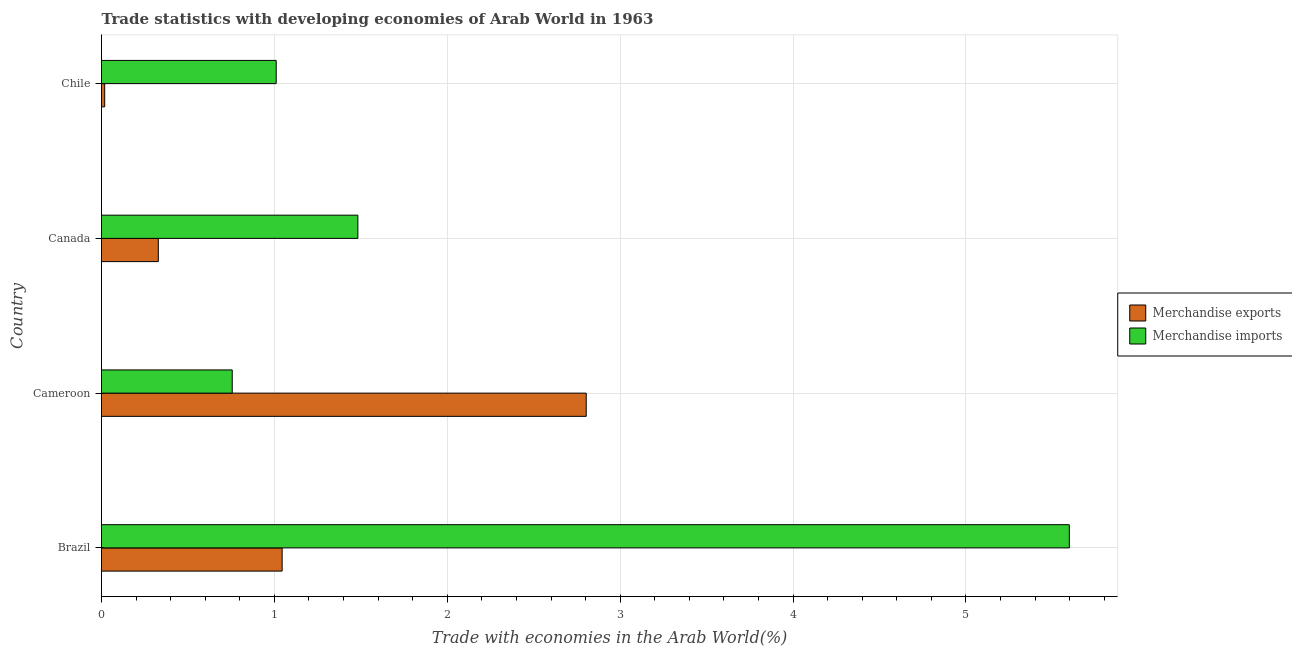How many different coloured bars are there?
Your answer should be compact. 2. How many bars are there on the 1st tick from the top?
Your response must be concise. 2. What is the label of the 2nd group of bars from the top?
Offer a very short reply. Canada. In how many cases, is the number of bars for a given country not equal to the number of legend labels?
Offer a very short reply. 0. What is the merchandise imports in Chile?
Your answer should be compact. 1.01. Across all countries, what is the maximum merchandise imports?
Offer a terse response. 5.6. Across all countries, what is the minimum merchandise imports?
Ensure brevity in your answer.  0.76. In which country was the merchandise imports maximum?
Your answer should be very brief. Brazil. In which country was the merchandise imports minimum?
Your answer should be very brief. Cameroon. What is the total merchandise imports in the graph?
Offer a terse response. 8.85. What is the difference between the merchandise exports in Canada and that in Chile?
Ensure brevity in your answer.  0.31. What is the difference between the merchandise exports in Brazil and the merchandise imports in Chile?
Your answer should be very brief. 0.03. What is the average merchandise exports per country?
Keep it short and to the point. 1.05. What is the difference between the merchandise exports and merchandise imports in Cameroon?
Offer a very short reply. 2.05. In how many countries, is the merchandise exports greater than 2.4 %?
Provide a short and direct response. 1. What is the ratio of the merchandise exports in Canada to that in Chile?
Your response must be concise. 17.8. Is the merchandise exports in Canada less than that in Chile?
Offer a terse response. No. Is the difference between the merchandise imports in Cameroon and Canada greater than the difference between the merchandise exports in Cameroon and Canada?
Make the answer very short. No. What is the difference between the highest and the second highest merchandise exports?
Provide a succinct answer. 1.76. What is the difference between the highest and the lowest merchandise exports?
Keep it short and to the point. 2.79. In how many countries, is the merchandise imports greater than the average merchandise imports taken over all countries?
Make the answer very short. 1. Is the sum of the merchandise imports in Cameroon and Canada greater than the maximum merchandise exports across all countries?
Your answer should be compact. No. What does the 1st bar from the bottom in Chile represents?
Give a very brief answer. Merchandise exports. Are all the bars in the graph horizontal?
Your answer should be compact. Yes. How many countries are there in the graph?
Ensure brevity in your answer.  4. What is the difference between two consecutive major ticks on the X-axis?
Your answer should be very brief. 1. What is the title of the graph?
Offer a terse response. Trade statistics with developing economies of Arab World in 1963. Does "Highest 20% of population" appear as one of the legend labels in the graph?
Your response must be concise. No. What is the label or title of the X-axis?
Your answer should be compact. Trade with economies in the Arab World(%). What is the label or title of the Y-axis?
Give a very brief answer. Country. What is the Trade with economies in the Arab World(%) in Merchandise exports in Brazil?
Ensure brevity in your answer.  1.04. What is the Trade with economies in the Arab World(%) in Merchandise imports in Brazil?
Provide a short and direct response. 5.6. What is the Trade with economies in the Arab World(%) in Merchandise exports in Cameroon?
Offer a very short reply. 2.8. What is the Trade with economies in the Arab World(%) in Merchandise imports in Cameroon?
Offer a very short reply. 0.76. What is the Trade with economies in the Arab World(%) of Merchandise exports in Canada?
Ensure brevity in your answer.  0.33. What is the Trade with economies in the Arab World(%) in Merchandise imports in Canada?
Your answer should be compact. 1.48. What is the Trade with economies in the Arab World(%) of Merchandise exports in Chile?
Offer a terse response. 0.02. What is the Trade with economies in the Arab World(%) in Merchandise imports in Chile?
Keep it short and to the point. 1.01. Across all countries, what is the maximum Trade with economies in the Arab World(%) in Merchandise exports?
Provide a short and direct response. 2.8. Across all countries, what is the maximum Trade with economies in the Arab World(%) of Merchandise imports?
Offer a very short reply. 5.6. Across all countries, what is the minimum Trade with economies in the Arab World(%) in Merchandise exports?
Your answer should be compact. 0.02. Across all countries, what is the minimum Trade with economies in the Arab World(%) of Merchandise imports?
Give a very brief answer. 0.76. What is the total Trade with economies in the Arab World(%) of Merchandise exports in the graph?
Provide a short and direct response. 4.2. What is the total Trade with economies in the Arab World(%) of Merchandise imports in the graph?
Your answer should be very brief. 8.85. What is the difference between the Trade with economies in the Arab World(%) in Merchandise exports in Brazil and that in Cameroon?
Offer a terse response. -1.76. What is the difference between the Trade with economies in the Arab World(%) in Merchandise imports in Brazil and that in Cameroon?
Give a very brief answer. 4.84. What is the difference between the Trade with economies in the Arab World(%) of Merchandise exports in Brazil and that in Canada?
Provide a short and direct response. 0.72. What is the difference between the Trade with economies in the Arab World(%) of Merchandise imports in Brazil and that in Canada?
Make the answer very short. 4.12. What is the difference between the Trade with economies in the Arab World(%) of Merchandise exports in Brazil and that in Chile?
Your answer should be very brief. 1.03. What is the difference between the Trade with economies in the Arab World(%) of Merchandise imports in Brazil and that in Chile?
Ensure brevity in your answer.  4.59. What is the difference between the Trade with economies in the Arab World(%) in Merchandise exports in Cameroon and that in Canada?
Your answer should be compact. 2.48. What is the difference between the Trade with economies in the Arab World(%) of Merchandise imports in Cameroon and that in Canada?
Provide a short and direct response. -0.73. What is the difference between the Trade with economies in the Arab World(%) of Merchandise exports in Cameroon and that in Chile?
Make the answer very short. 2.79. What is the difference between the Trade with economies in the Arab World(%) of Merchandise imports in Cameroon and that in Chile?
Your answer should be compact. -0.25. What is the difference between the Trade with economies in the Arab World(%) of Merchandise exports in Canada and that in Chile?
Offer a very short reply. 0.31. What is the difference between the Trade with economies in the Arab World(%) of Merchandise imports in Canada and that in Chile?
Offer a very short reply. 0.47. What is the difference between the Trade with economies in the Arab World(%) of Merchandise exports in Brazil and the Trade with economies in the Arab World(%) of Merchandise imports in Cameroon?
Provide a short and direct response. 0.29. What is the difference between the Trade with economies in the Arab World(%) in Merchandise exports in Brazil and the Trade with economies in the Arab World(%) in Merchandise imports in Canada?
Your response must be concise. -0.44. What is the difference between the Trade with economies in the Arab World(%) in Merchandise exports in Brazil and the Trade with economies in the Arab World(%) in Merchandise imports in Chile?
Make the answer very short. 0.03. What is the difference between the Trade with economies in the Arab World(%) in Merchandise exports in Cameroon and the Trade with economies in the Arab World(%) in Merchandise imports in Canada?
Give a very brief answer. 1.32. What is the difference between the Trade with economies in the Arab World(%) in Merchandise exports in Cameroon and the Trade with economies in the Arab World(%) in Merchandise imports in Chile?
Provide a succinct answer. 1.79. What is the difference between the Trade with economies in the Arab World(%) of Merchandise exports in Canada and the Trade with economies in the Arab World(%) of Merchandise imports in Chile?
Provide a short and direct response. -0.68. What is the average Trade with economies in the Arab World(%) in Merchandise exports per country?
Provide a succinct answer. 1.05. What is the average Trade with economies in the Arab World(%) of Merchandise imports per country?
Give a very brief answer. 2.21. What is the difference between the Trade with economies in the Arab World(%) in Merchandise exports and Trade with economies in the Arab World(%) in Merchandise imports in Brazil?
Offer a terse response. -4.55. What is the difference between the Trade with economies in the Arab World(%) of Merchandise exports and Trade with economies in the Arab World(%) of Merchandise imports in Cameroon?
Your answer should be very brief. 2.05. What is the difference between the Trade with economies in the Arab World(%) in Merchandise exports and Trade with economies in the Arab World(%) in Merchandise imports in Canada?
Your answer should be very brief. -1.15. What is the difference between the Trade with economies in the Arab World(%) of Merchandise exports and Trade with economies in the Arab World(%) of Merchandise imports in Chile?
Provide a succinct answer. -0.99. What is the ratio of the Trade with economies in the Arab World(%) of Merchandise exports in Brazil to that in Cameroon?
Make the answer very short. 0.37. What is the ratio of the Trade with economies in the Arab World(%) of Merchandise imports in Brazil to that in Cameroon?
Keep it short and to the point. 7.4. What is the ratio of the Trade with economies in the Arab World(%) in Merchandise exports in Brazil to that in Canada?
Ensure brevity in your answer.  3.18. What is the ratio of the Trade with economies in the Arab World(%) of Merchandise imports in Brazil to that in Canada?
Make the answer very short. 3.78. What is the ratio of the Trade with economies in the Arab World(%) of Merchandise exports in Brazil to that in Chile?
Keep it short and to the point. 56.59. What is the ratio of the Trade with economies in the Arab World(%) in Merchandise imports in Brazil to that in Chile?
Provide a succinct answer. 5.54. What is the ratio of the Trade with economies in the Arab World(%) in Merchandise exports in Cameroon to that in Canada?
Make the answer very short. 8.53. What is the ratio of the Trade with economies in the Arab World(%) of Merchandise imports in Cameroon to that in Canada?
Your response must be concise. 0.51. What is the ratio of the Trade with economies in the Arab World(%) of Merchandise exports in Cameroon to that in Chile?
Give a very brief answer. 151.85. What is the ratio of the Trade with economies in the Arab World(%) of Merchandise imports in Cameroon to that in Chile?
Provide a short and direct response. 0.75. What is the ratio of the Trade with economies in the Arab World(%) of Merchandise exports in Canada to that in Chile?
Make the answer very short. 17.8. What is the ratio of the Trade with economies in the Arab World(%) in Merchandise imports in Canada to that in Chile?
Keep it short and to the point. 1.47. What is the difference between the highest and the second highest Trade with economies in the Arab World(%) of Merchandise exports?
Provide a short and direct response. 1.76. What is the difference between the highest and the second highest Trade with economies in the Arab World(%) in Merchandise imports?
Offer a very short reply. 4.12. What is the difference between the highest and the lowest Trade with economies in the Arab World(%) of Merchandise exports?
Your response must be concise. 2.79. What is the difference between the highest and the lowest Trade with economies in the Arab World(%) in Merchandise imports?
Give a very brief answer. 4.84. 